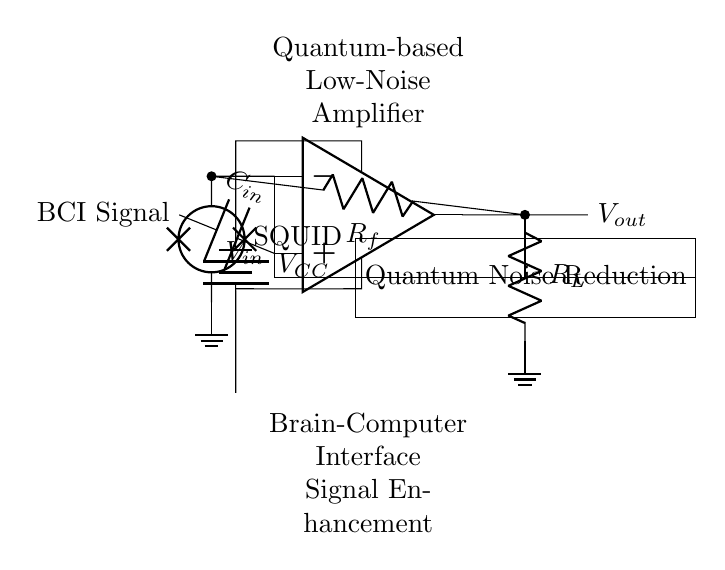What type of amplifier is represented in the circuit? The circuit represents a low-noise amplifier, specifically designed to enhance brain-computer interface signals. It is articulated by the label above the op-amp in the diagram.
Answer: low-noise amplifier What component is used for feedback? The feedback is provided by a resistor labeled as R_f, connecting the output to the inverting input of the op-amp. This is a common practice in amplifier circuits to stabilize and set the gain.
Answer: R_f What is the function of the SQUID in this circuit? The SQUID, which stands for Superconducting Quantum Interference Device, is used for quantum noise reduction in the circuit. This helps in minimizing the noise effect, which is critical for amplifying weak brain-computer interface signals.
Answer: quantum noise reduction What is the input signal to the amplifier? The input signal to the amplifier is labeled as "BCI Signal," indicating that it is sourced from a brain-computer interface, which directly connects to the non-inverting terminal of the op-amp through the capacitor C_in.
Answer: BCI signal How many power supplies are indicated in the circuit? The circuit shows one power supply labeled as V_CC, which provides the necessary voltage for the op-amp to operate effectively. This is evident from the connection shown from the op-amp's upper terminal to the battery in the diagram.
Answer: one What is the role of the capacitor labeled C_in? The capacitor C_in serves to couple the input BCI signal to the non-inverting terminal of the op-amp. This ensures only the AC signal is amplified while blocking any DC components from the input signal.
Answer: coupling What does R_L represent in the output section? R_L represents the load resistor connected to the output of the amplifier. This resistor is important in defining the load seen by the amplifier and influences the overall gain and performance of the circuit.
Answer: load resistor 